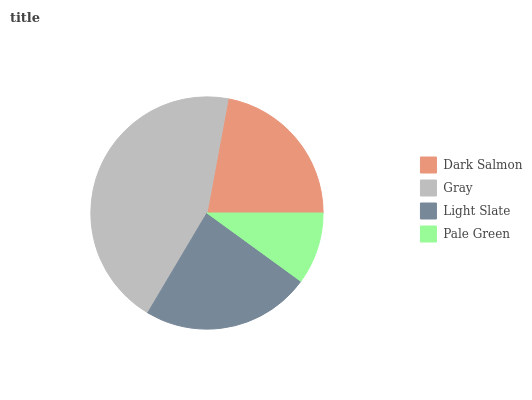Is Pale Green the minimum?
Answer yes or no. Yes. Is Gray the maximum?
Answer yes or no. Yes. Is Light Slate the minimum?
Answer yes or no. No. Is Light Slate the maximum?
Answer yes or no. No. Is Gray greater than Light Slate?
Answer yes or no. Yes. Is Light Slate less than Gray?
Answer yes or no. Yes. Is Light Slate greater than Gray?
Answer yes or no. No. Is Gray less than Light Slate?
Answer yes or no. No. Is Light Slate the high median?
Answer yes or no. Yes. Is Dark Salmon the low median?
Answer yes or no. Yes. Is Dark Salmon the high median?
Answer yes or no. No. Is Gray the low median?
Answer yes or no. No. 